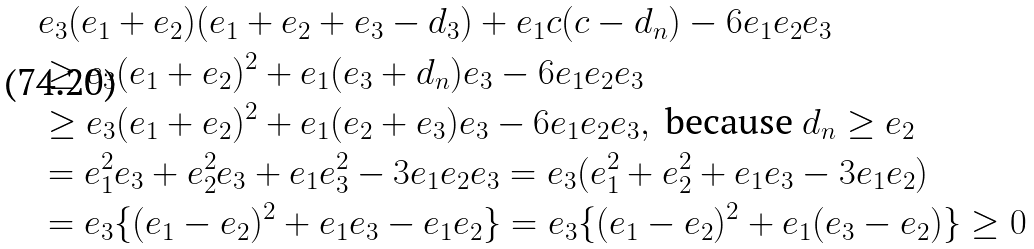Convert formula to latex. <formula><loc_0><loc_0><loc_500><loc_500>& e _ { 3 } ( e _ { 1 } + e _ { 2 } ) ( e _ { 1 } + e _ { 2 } + e _ { 3 } - d _ { 3 } ) + e _ { 1 } c ( c - d _ { n } ) - 6 e _ { 1 } e _ { 2 } e _ { 3 } \\ & \geq e _ { 3 } ( e _ { 1 } + e _ { 2 } ) ^ { 2 } + e _ { 1 } ( e _ { 3 } + d _ { n } ) e _ { 3 } - 6 e _ { 1 } e _ { 2 } e _ { 3 } \\ & \geq e _ { 3 } ( e _ { 1 } + e _ { 2 } ) ^ { 2 } + e _ { 1 } ( e _ { 2 } + e _ { 3 } ) e _ { 3 } - 6 e _ { 1 } e _ { 2 } e _ { 3 } , \text { because } d _ { n } \geq e _ { 2 } \\ & = e _ { 1 } ^ { 2 } e _ { 3 } + e _ { 2 } ^ { 2 } e _ { 3 } + e _ { 1 } e _ { 3 } ^ { 2 } - 3 e _ { 1 } e _ { 2 } e _ { 3 } = e _ { 3 } ( e _ { 1 } ^ { 2 } + e _ { 2 } ^ { 2 } + e _ { 1 } e _ { 3 } - 3 e _ { 1 } e _ { 2 } ) \\ & = e _ { 3 } \{ ( e _ { 1 } - e _ { 2 } ) ^ { 2 } + e _ { 1 } e _ { 3 } - e _ { 1 } e _ { 2 } \} = e _ { 3 } \{ ( e _ { 1 } - e _ { 2 } ) ^ { 2 } + e _ { 1 } ( e _ { 3 } - e _ { 2 } ) \} \geq 0</formula> 